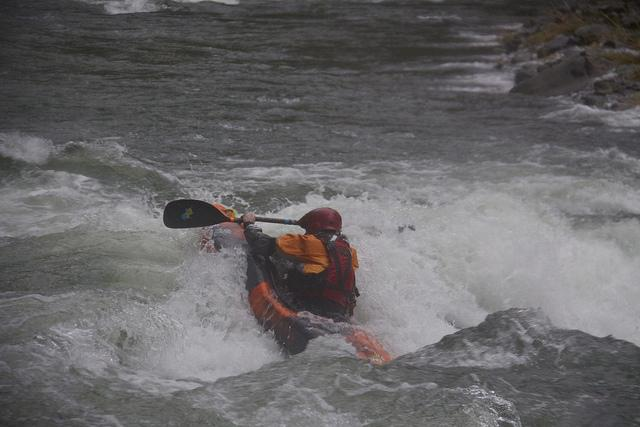What life threatening danger does this kayaker face if the waves get to high?

Choices:
A) drowning
B) burning
C) electrocution
D) punch drowning 